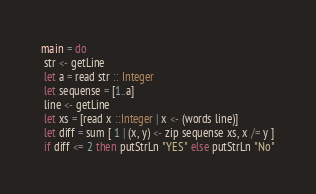Convert code to text. <code><loc_0><loc_0><loc_500><loc_500><_Haskell_>main = do
 str <- getLine
 let a = read str :: Integer
 let sequense = [1..a]
 line <- getLine
 let xs = [read x ::Integer | x <- (words line)]
 let diff = sum [ 1 | (x, y) <- zip sequense xs, x /= y ]
 if diff <= 2 then putStrLn "YES" else putStrLn "No"
</code> 